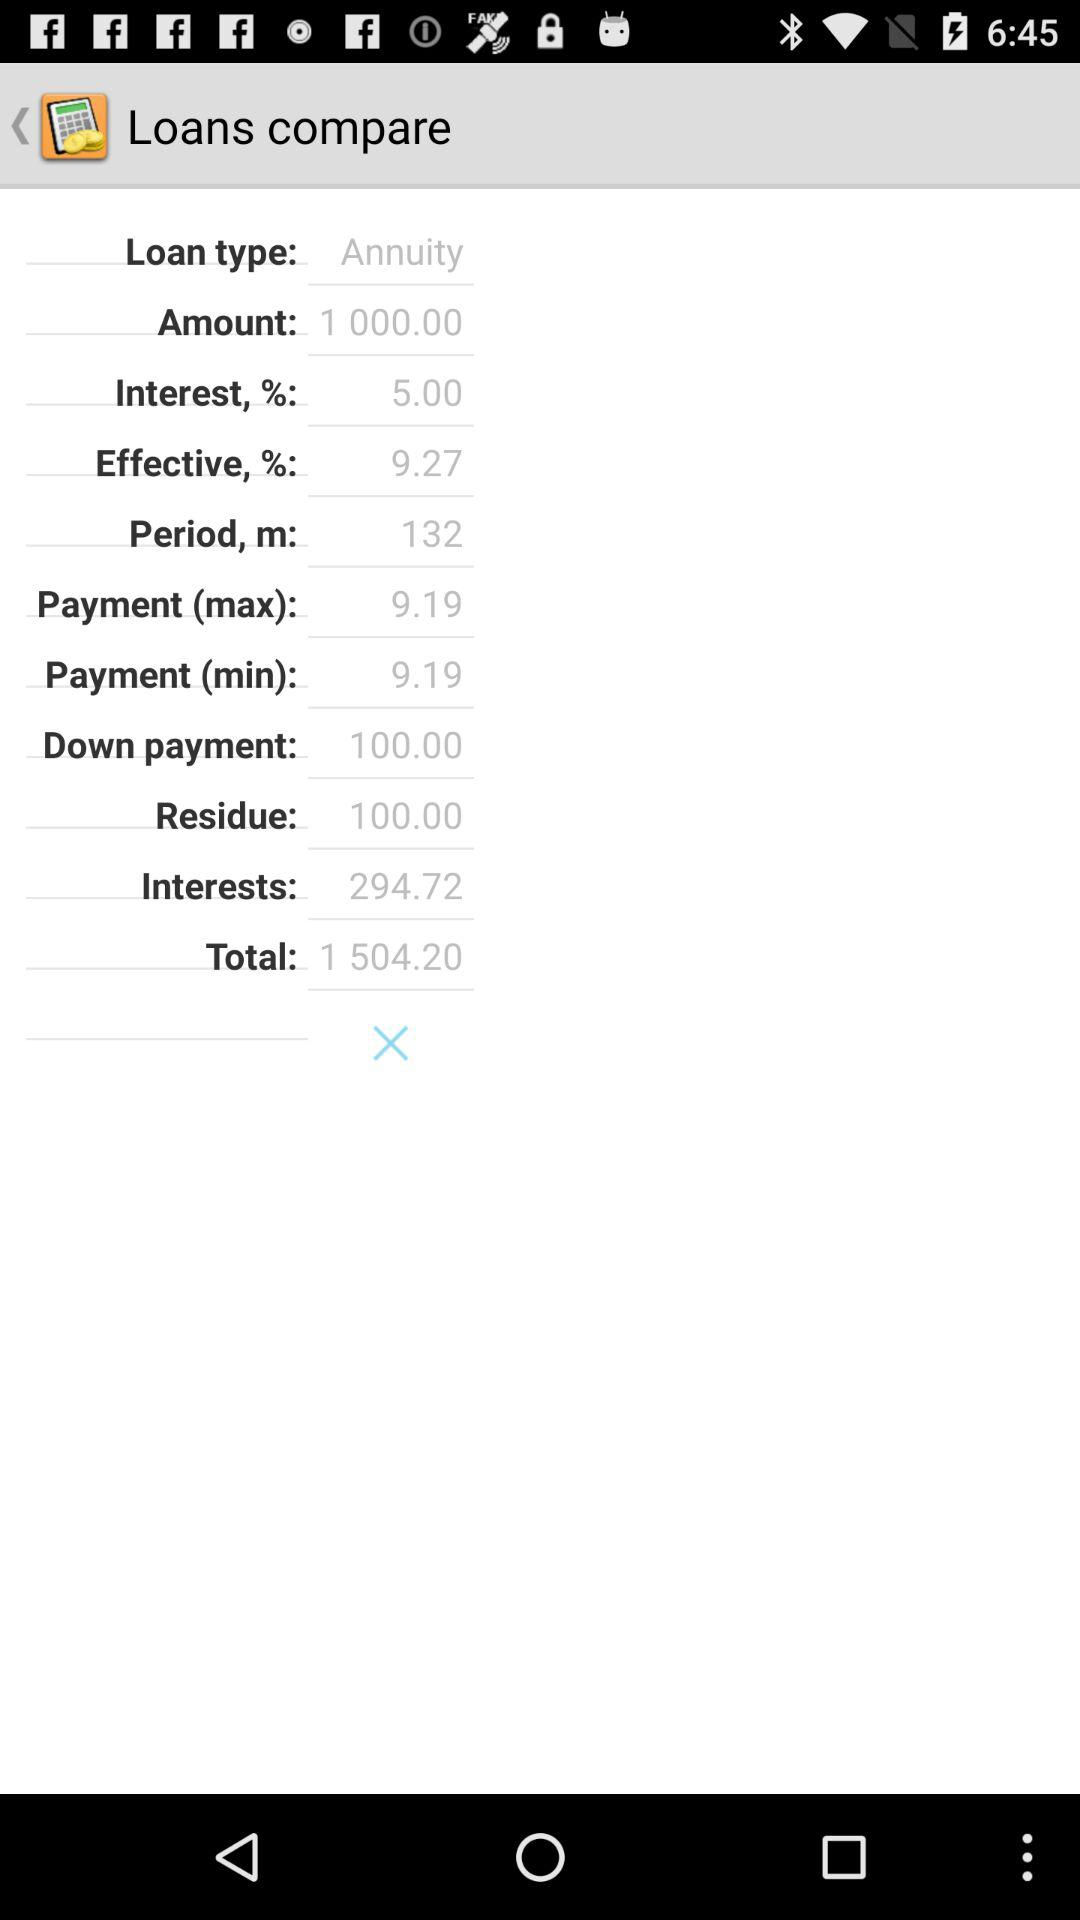What is the minimum payment amount? The minimum payment amount is 9.19. 